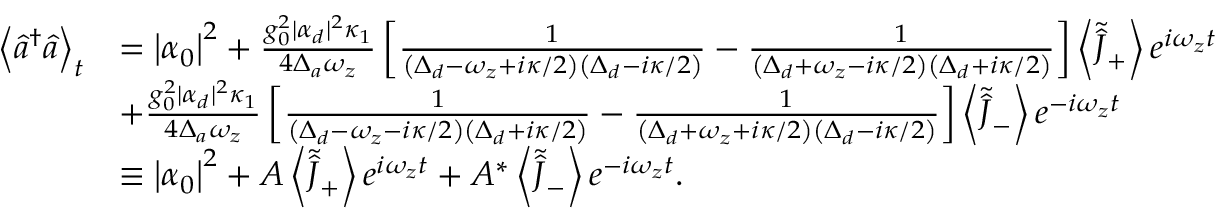Convert formula to latex. <formula><loc_0><loc_0><loc_500><loc_500>\begin{array} { r l } { \left \langle \hat { a } ^ { \dagger } \hat { a } \right \rangle _ { t } } & { = \left | \alpha _ { 0 } \right | ^ { 2 } + \frac { g _ { 0 } ^ { 2 } | \alpha _ { d } | ^ { 2 } \kappa _ { 1 } } { 4 \Delta _ { a } \omega _ { z } } \left [ \frac { 1 } { \left ( \Delta _ { d } - \omega _ { z } + i \kappa / 2 \right ) \left ( \Delta _ { d } - i \kappa / 2 \right ) } - \frac { 1 } { \left ( \Delta _ { d } + \omega _ { z } - i \kappa / 2 \right ) \left ( \Delta _ { d } + i \kappa / 2 \right ) } \right ] \left \langle \tilde { \hat { J } } _ { + } \right \rangle e ^ { i \omega _ { z } t } } \\ & { + \frac { g _ { 0 } ^ { 2 } | \alpha _ { d } | ^ { 2 } \kappa _ { 1 } } { 4 \Delta _ { a } \omega _ { z } } \left [ \frac { 1 } { \left ( \Delta _ { d } - \omega _ { z } - i \kappa / 2 \right ) \left ( \Delta _ { d } + i \kappa / 2 \right ) } - \frac { 1 } { \left ( \Delta _ { d } + \omega _ { z } + i \kappa / 2 \right ) \left ( \Delta _ { d } - i \kappa / 2 \right ) } \right ] \left \langle \tilde { \hat { J } } _ { - } \right \rangle e ^ { - i \omega _ { z } t } } \\ & { \equiv \left | \alpha _ { 0 } \right | ^ { 2 } + A \left \langle \tilde { \hat { J } } _ { + } \right \rangle e ^ { i \omega _ { z } t } + A ^ { * } \left \langle \tilde { \hat { J } } _ { - } \right \rangle e ^ { - i \omega _ { z } t } . } \end{array}</formula> 